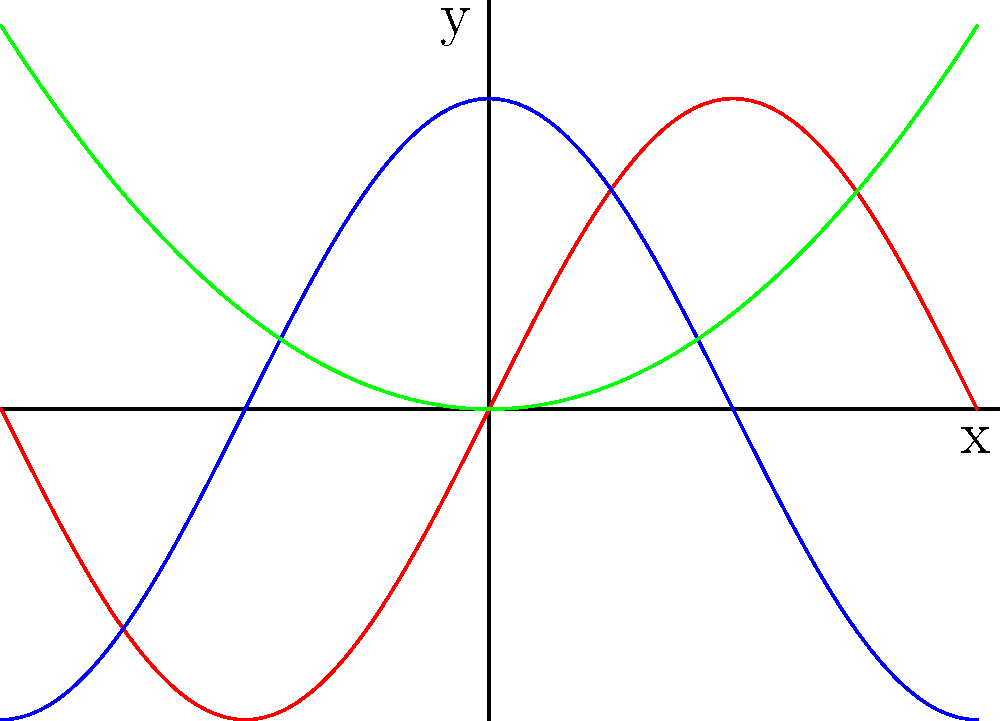As an innovative painter, you're creating an abstract composition using mathematical functions on a coordinate plane. You've plotted three functions: $f(x)=2\sin(x)$ in red, $g(x)=2\cos(x)$ in blue, and $h(x)=\frac{x^2}{4}$ in green, all on the interval $[-\pi,\pi]$. At how many points do all three functions intersect within this interval? To find the number of intersection points for all three functions, we need to follow these steps:

1) First, we need to find the points where $f(x) = g(x) = h(x)$. This means solving the equation:

   $$2\sin(x) = 2\cos(x) = \frac{x^2}{4}$$

2) We can simplify this by considering $\sin(x) = \cos(x)$ first. This occurs when $x = \frac{\pi}{4}$ and $x = \frac{5\pi}{4}$ in the interval $[-\pi,\pi]$.

3) Now, we need to check if $h(x) = \frac{x^2}{4}$ equals $2\sin(x)$ at these points:

   For $x = \frac{\pi}{4}$:
   $2\sin(\frac{\pi}{4}) = 2 \cdot \frac{\sqrt{2}}{2} = \sqrt{2} \approx 1.414$
   $\frac{(\frac{\pi}{4})^2}{4} = \frac{\pi^2}{64} \approx 0.154$

   For $x = \frac{5\pi}{4}$:
   $2\sin(\frac{5\pi}{4}) = -2 \cdot \frac{\sqrt{2}}{2} = -\sqrt{2} \approx -1.414$
   $\frac{(\frac{5\pi}{4})^2}{4} = \frac{25\pi^2}{64} \approx 3.858$

4) We can see that $h(x)$ doesn't equal $f(x)$ and $g(x)$ at these points.

5) By observing the graph, we can see that there are two points where all three functions intersect. These occur symmetrically around the y-axis.

Therefore, all three functions intersect at 2 points within the given interval.
Answer: 2 points 